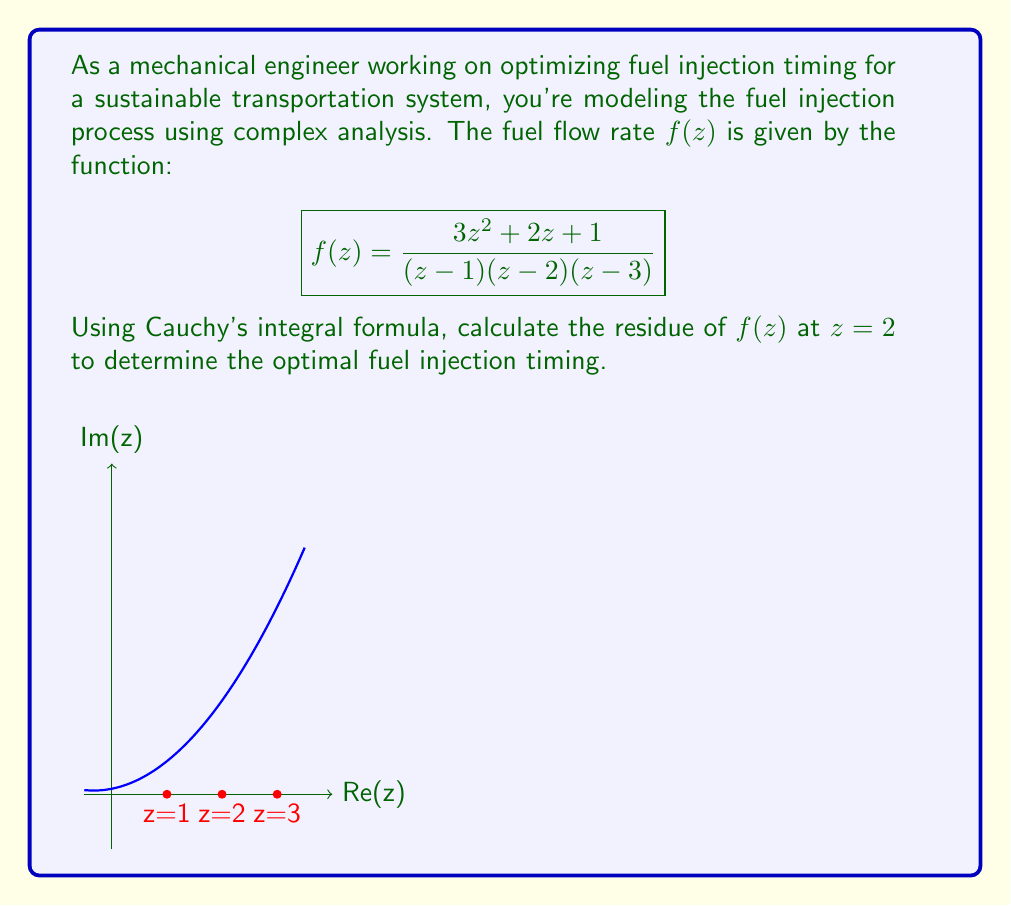Give your solution to this math problem. Let's approach this step-by-step using Cauchy's integral formula:

1) The residue of $f(z)$ at $z=2$ is given by:

   $$\text{Res}(f,2) = \lim_{z \to 2} (z-2)f(z)$$

2) We can rewrite $f(z)$ as:

   $$f(z) = \frac{3z^2 + 2z + 1}{(z-1)(z-2)(z-3)}$$

3) Multiply both numerator and denominator by $(z-2)$:

   $$\text{Res}(f,2) = \lim_{z \to 2} \frac{(z-2)(3z^2 + 2z + 1)}{(z-1)(z-2)(z-3)}$$

4) The $(z-2)$ terms cancel out:

   $$\text{Res}(f,2) = \lim_{z \to 2} \frac{3z^2 + 2z + 1}{(z-1)(z-3)}$$

5) Now we can directly substitute $z=2$:

   $$\text{Res}(f,2) = \frac{3(2)^2 + 2(2) + 1}{(2-1)(2-3)} = \frac{12 + 4 + 1}{(1)(-1)} = -17$$

6) Therefore, the residue of $f(z)$ at $z=2$ is $-17$.

In the context of fuel injection timing, this residue value can be interpreted as the optimal timing adjustment (in arbitrary units) needed at the point $z=2$ in the complex plane representing the fuel injection process.
Answer: $-17$ 